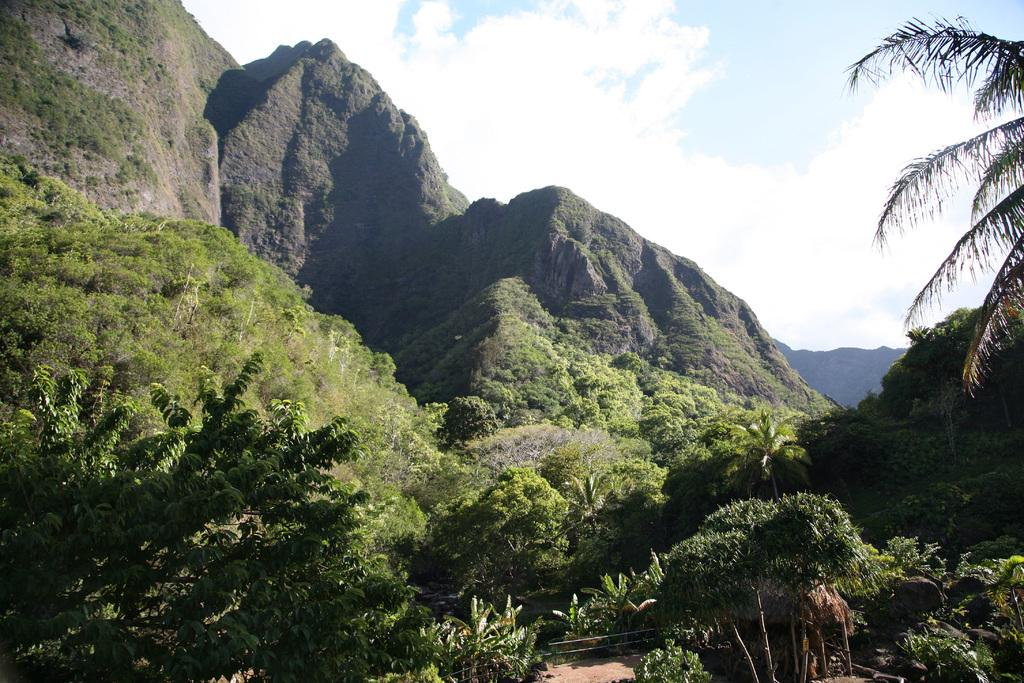What type of natural landform can be seen in the image? There are mountains in the image. What type of vegetation is present in the image? There are trees and plants in the image. How does the beetle balance on the mountain in the image? There is no beetle present in the image, so it cannot be determined how it would balance on the mountain. 